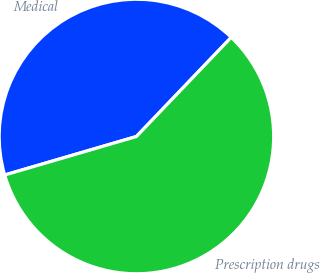<chart> <loc_0><loc_0><loc_500><loc_500><pie_chart><fcel>Medical<fcel>Prescription drugs<nl><fcel>41.67%<fcel>58.33%<nl></chart> 